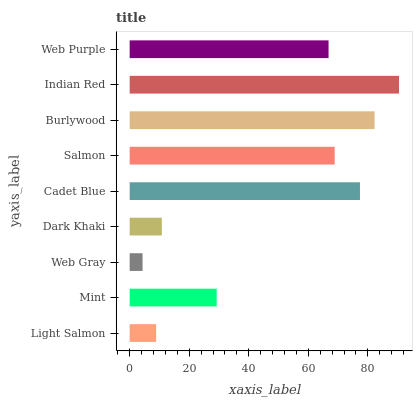Is Web Gray the minimum?
Answer yes or no. Yes. Is Indian Red the maximum?
Answer yes or no. Yes. Is Mint the minimum?
Answer yes or no. No. Is Mint the maximum?
Answer yes or no. No. Is Mint greater than Light Salmon?
Answer yes or no. Yes. Is Light Salmon less than Mint?
Answer yes or no. Yes. Is Light Salmon greater than Mint?
Answer yes or no. No. Is Mint less than Light Salmon?
Answer yes or no. No. Is Web Purple the high median?
Answer yes or no. Yes. Is Web Purple the low median?
Answer yes or no. Yes. Is Burlywood the high median?
Answer yes or no. No. Is Salmon the low median?
Answer yes or no. No. 